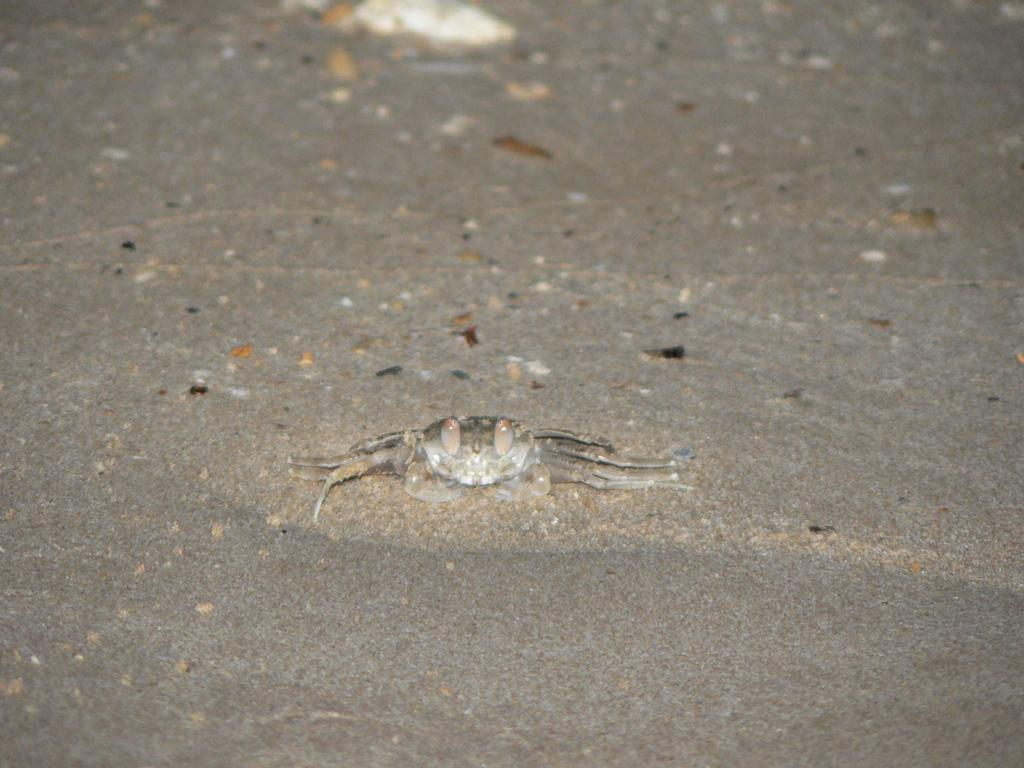What is the main subject of the image? There is a crab in the image. Where is the crab located in the image? The crab is in the center of the image. What color is the crab? The crab is ash-colored. What type of sweater is the crab wearing in the image? There is no sweater present in the image, as crabs do not wear clothing. 